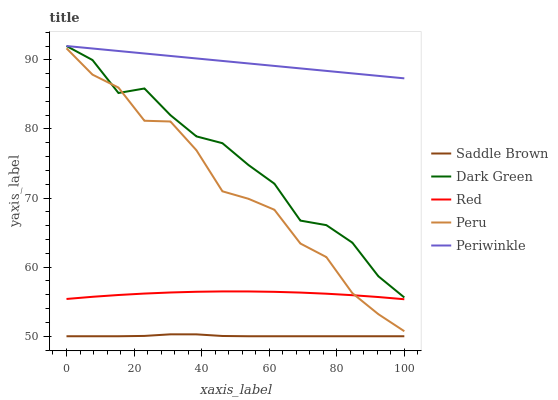Does Saddle Brown have the minimum area under the curve?
Answer yes or no. Yes. Does Periwinkle have the maximum area under the curve?
Answer yes or no. Yes. Does Periwinkle have the minimum area under the curve?
Answer yes or no. No. Does Saddle Brown have the maximum area under the curve?
Answer yes or no. No. Is Periwinkle the smoothest?
Answer yes or no. Yes. Is Peru the roughest?
Answer yes or no. Yes. Is Saddle Brown the smoothest?
Answer yes or no. No. Is Saddle Brown the roughest?
Answer yes or no. No. Does Saddle Brown have the lowest value?
Answer yes or no. Yes. Does Periwinkle have the lowest value?
Answer yes or no. No. Does Dark Green have the highest value?
Answer yes or no. Yes. Does Saddle Brown have the highest value?
Answer yes or no. No. Is Peru less than Periwinkle?
Answer yes or no. Yes. Is Periwinkle greater than Peru?
Answer yes or no. Yes. Does Dark Green intersect Peru?
Answer yes or no. Yes. Is Dark Green less than Peru?
Answer yes or no. No. Is Dark Green greater than Peru?
Answer yes or no. No. Does Peru intersect Periwinkle?
Answer yes or no. No. 